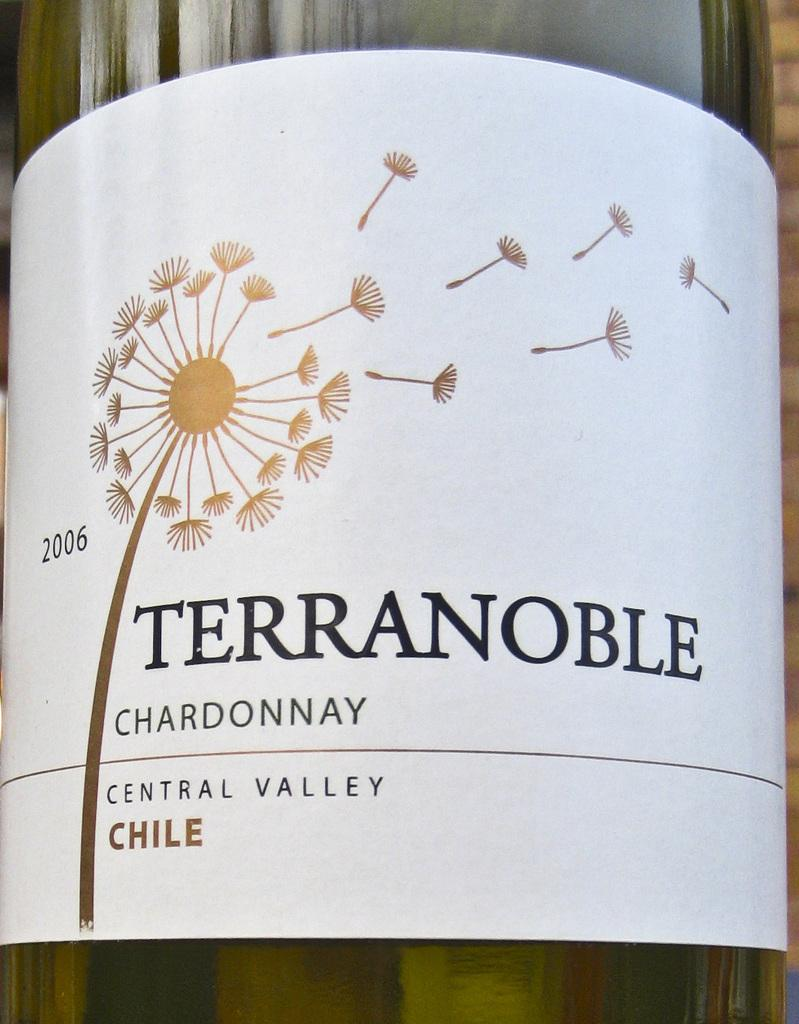<image>
Write a terse but informative summary of the picture. The bottle is of Terranoble chardonnay, 2006 vintage.. 